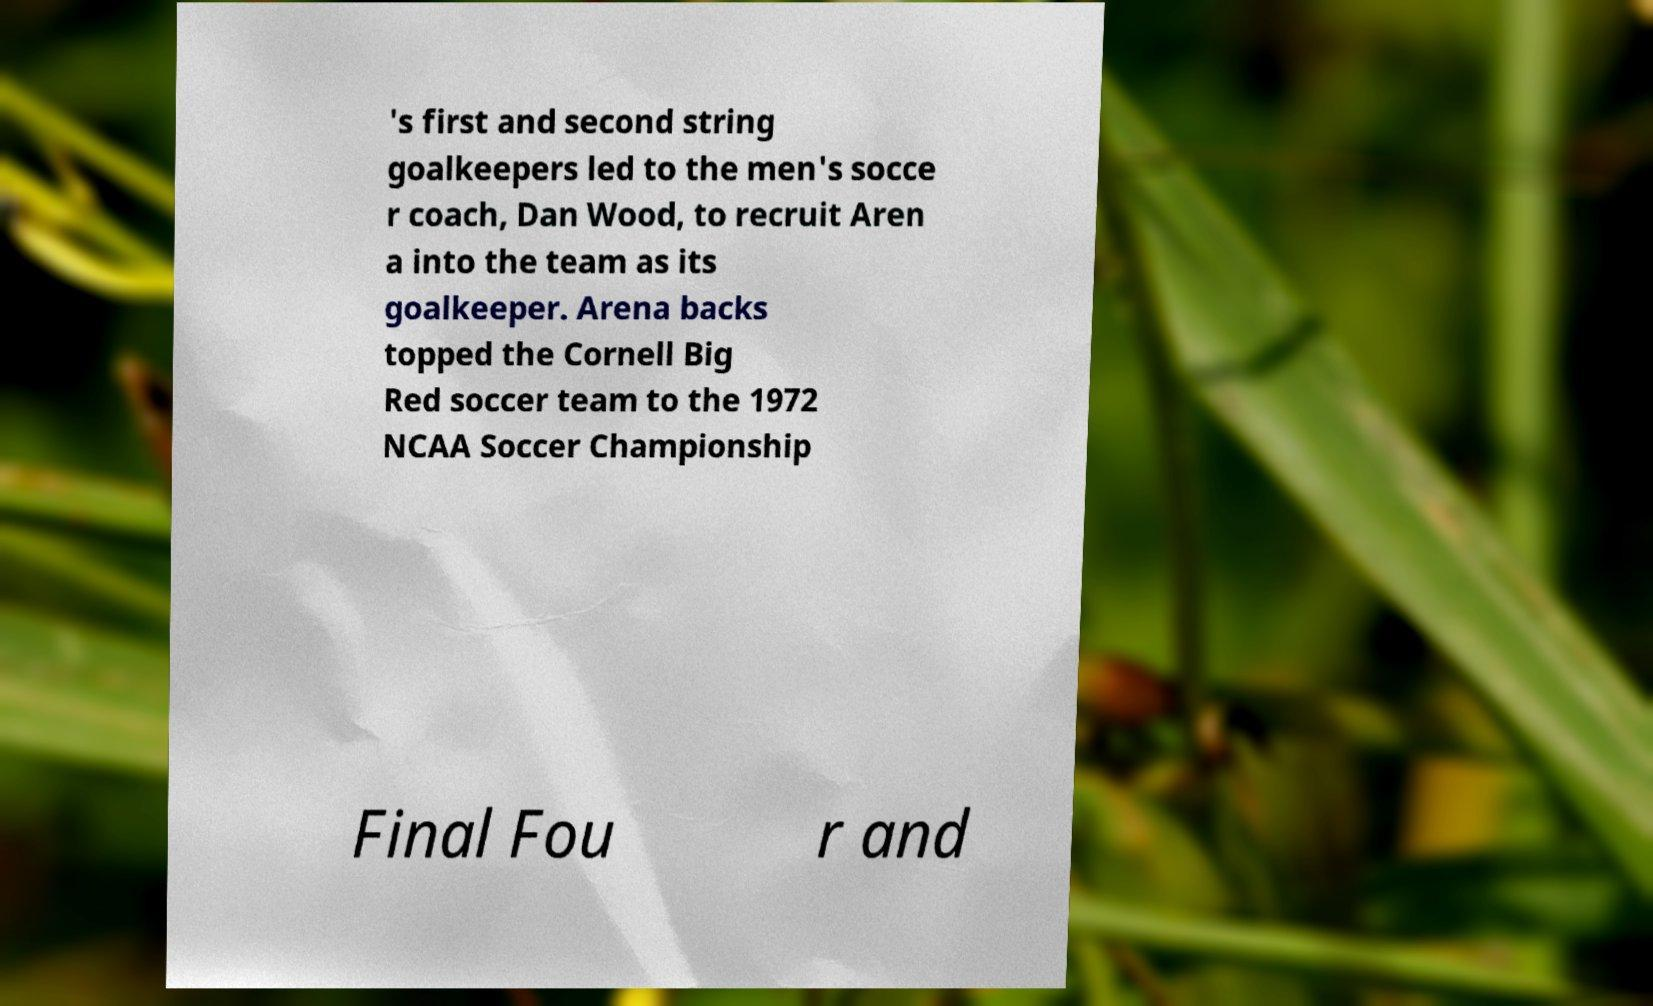Could you assist in decoding the text presented in this image and type it out clearly? 's first and second string goalkeepers led to the men's socce r coach, Dan Wood, to recruit Aren a into the team as its goalkeeper. Arena backs topped the Cornell Big Red soccer team to the 1972 NCAA Soccer Championship Final Fou r and 